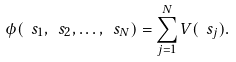Convert formula to latex. <formula><loc_0><loc_0><loc_500><loc_500>\phi ( \ s _ { 1 } , \ s _ { 2 } , \dots , \ s _ { N } ) = \sum _ { j = 1 } ^ { N } V ( \ s _ { j } ) .</formula> 